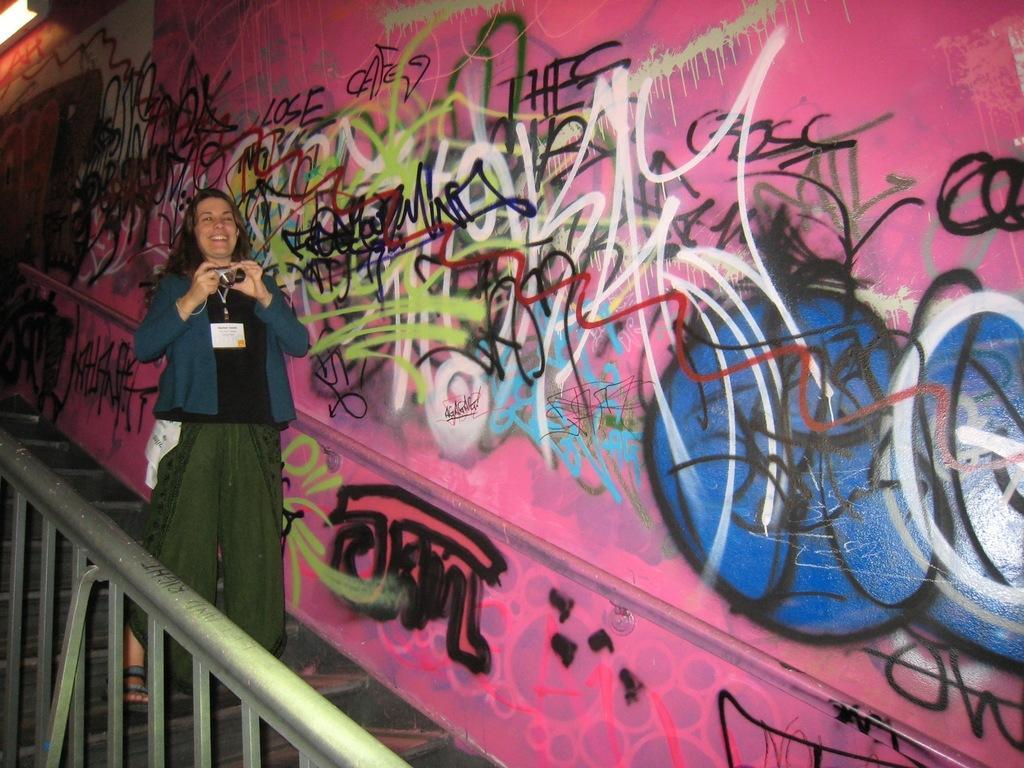How would you summarize this image in a sentence or two? In this image, we can see a person holding an object is standing. We can see the wall with some art. We can also see some stairs and the railing. We can also see an object in the top left corner. 